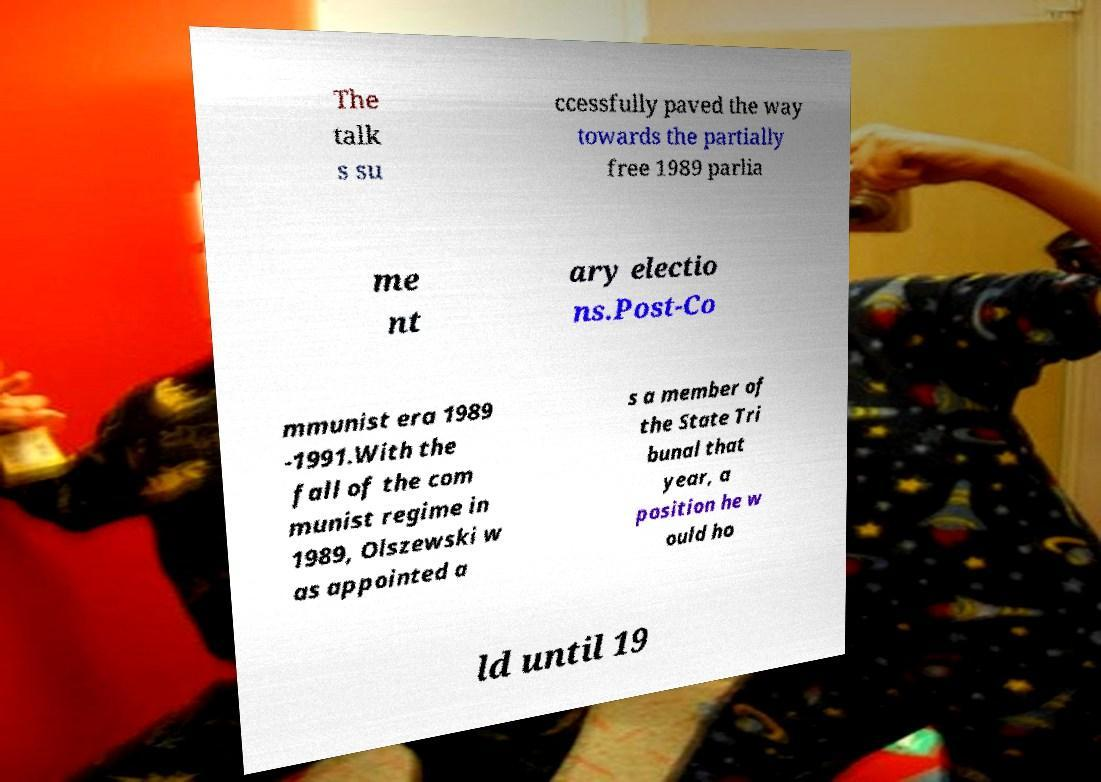Could you assist in decoding the text presented in this image and type it out clearly? The talk s su ccessfully paved the way towards the partially free 1989 parlia me nt ary electio ns.Post-Co mmunist era 1989 -1991.With the fall of the com munist regime in 1989, Olszewski w as appointed a s a member of the State Tri bunal that year, a position he w ould ho ld until 19 